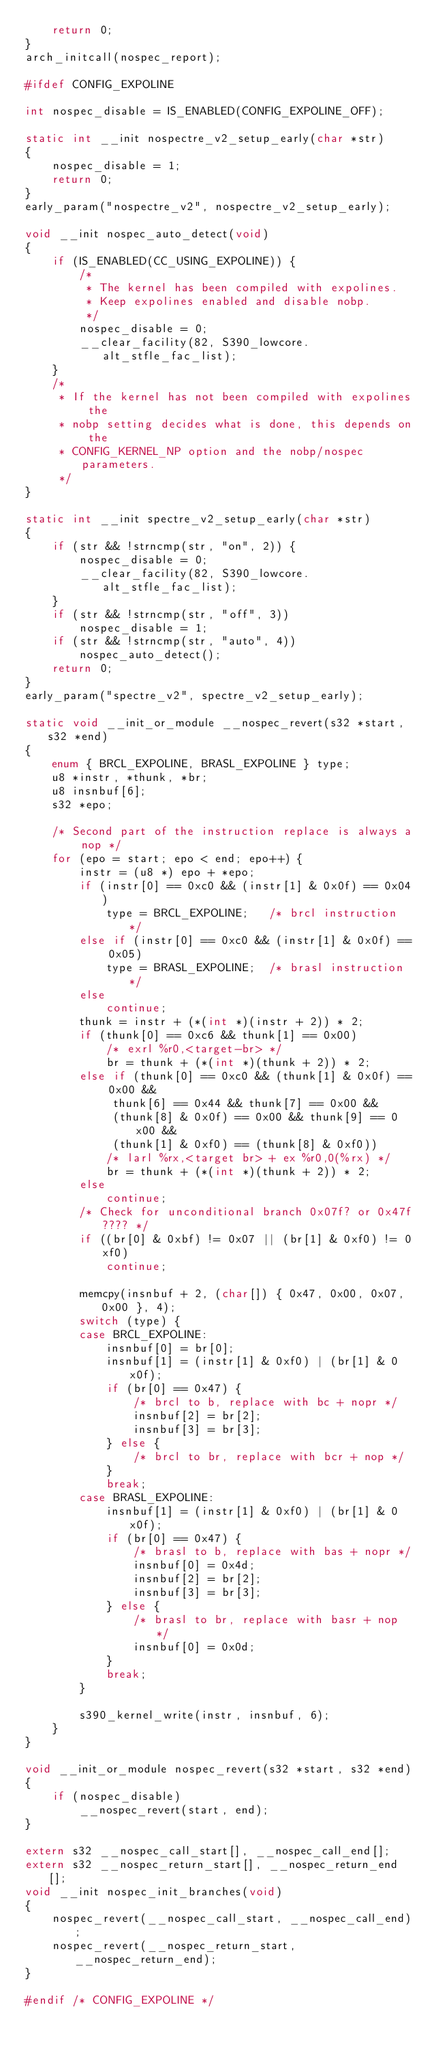Convert code to text. <code><loc_0><loc_0><loc_500><loc_500><_C_>	return 0;
}
arch_initcall(nospec_report);

#ifdef CONFIG_EXPOLINE

int nospec_disable = IS_ENABLED(CONFIG_EXPOLINE_OFF);

static int __init nospectre_v2_setup_early(char *str)
{
	nospec_disable = 1;
	return 0;
}
early_param("nospectre_v2", nospectre_v2_setup_early);

void __init nospec_auto_detect(void)
{
	if (IS_ENABLED(CC_USING_EXPOLINE)) {
		/*
		 * The kernel has been compiled with expolines.
		 * Keep expolines enabled and disable nobp.
		 */
		nospec_disable = 0;
		__clear_facility(82, S390_lowcore.alt_stfle_fac_list);
	}
	/*
	 * If the kernel has not been compiled with expolines the
	 * nobp setting decides what is done, this depends on the
	 * CONFIG_KERNEL_NP option and the nobp/nospec parameters.
	 */
}

static int __init spectre_v2_setup_early(char *str)
{
	if (str && !strncmp(str, "on", 2)) {
		nospec_disable = 0;
		__clear_facility(82, S390_lowcore.alt_stfle_fac_list);
	}
	if (str && !strncmp(str, "off", 3))
		nospec_disable = 1;
	if (str && !strncmp(str, "auto", 4))
		nospec_auto_detect();
	return 0;
}
early_param("spectre_v2", spectre_v2_setup_early);

static void __init_or_module __nospec_revert(s32 *start, s32 *end)
{
	enum { BRCL_EXPOLINE, BRASL_EXPOLINE } type;
	u8 *instr, *thunk, *br;
	u8 insnbuf[6];
	s32 *epo;

	/* Second part of the instruction replace is always a nop */
	for (epo = start; epo < end; epo++) {
		instr = (u8 *) epo + *epo;
		if (instr[0] == 0xc0 && (instr[1] & 0x0f) == 0x04)
			type = BRCL_EXPOLINE;	/* brcl instruction */
		else if (instr[0] == 0xc0 && (instr[1] & 0x0f) == 0x05)
			type = BRASL_EXPOLINE;	/* brasl instruction */
		else
			continue;
		thunk = instr + (*(int *)(instr + 2)) * 2;
		if (thunk[0] == 0xc6 && thunk[1] == 0x00)
			/* exrl %r0,<target-br> */
			br = thunk + (*(int *)(thunk + 2)) * 2;
		else if (thunk[0] == 0xc0 && (thunk[1] & 0x0f) == 0x00 &&
			 thunk[6] == 0x44 && thunk[7] == 0x00 &&
			 (thunk[8] & 0x0f) == 0x00 && thunk[9] == 0x00 &&
			 (thunk[1] & 0xf0) == (thunk[8] & 0xf0))
			/* larl %rx,<target br> + ex %r0,0(%rx) */
			br = thunk + (*(int *)(thunk + 2)) * 2;
		else
			continue;
		/* Check for unconditional branch 0x07f? or 0x47f???? */
		if ((br[0] & 0xbf) != 0x07 || (br[1] & 0xf0) != 0xf0)
			continue;

		memcpy(insnbuf + 2, (char[]) { 0x47, 0x00, 0x07, 0x00 }, 4);
		switch (type) {
		case BRCL_EXPOLINE:
			insnbuf[0] = br[0];
			insnbuf[1] = (instr[1] & 0xf0) | (br[1] & 0x0f);
			if (br[0] == 0x47) {
				/* brcl to b, replace with bc + nopr */
				insnbuf[2] = br[2];
				insnbuf[3] = br[3];
			} else {
				/* brcl to br, replace with bcr + nop */
			}
			break;
		case BRASL_EXPOLINE:
			insnbuf[1] = (instr[1] & 0xf0) | (br[1] & 0x0f);
			if (br[0] == 0x47) {
				/* brasl to b, replace with bas + nopr */
				insnbuf[0] = 0x4d;
				insnbuf[2] = br[2];
				insnbuf[3] = br[3];
			} else {
				/* brasl to br, replace with basr + nop */
				insnbuf[0] = 0x0d;
			}
			break;
		}

		s390_kernel_write(instr, insnbuf, 6);
	}
}

void __init_or_module nospec_revert(s32 *start, s32 *end)
{
	if (nospec_disable)
		__nospec_revert(start, end);
}

extern s32 __nospec_call_start[], __nospec_call_end[];
extern s32 __nospec_return_start[], __nospec_return_end[];
void __init nospec_init_branches(void)
{
	nospec_revert(__nospec_call_start, __nospec_call_end);
	nospec_revert(__nospec_return_start, __nospec_return_end);
}

#endif /* CONFIG_EXPOLINE */
</code> 